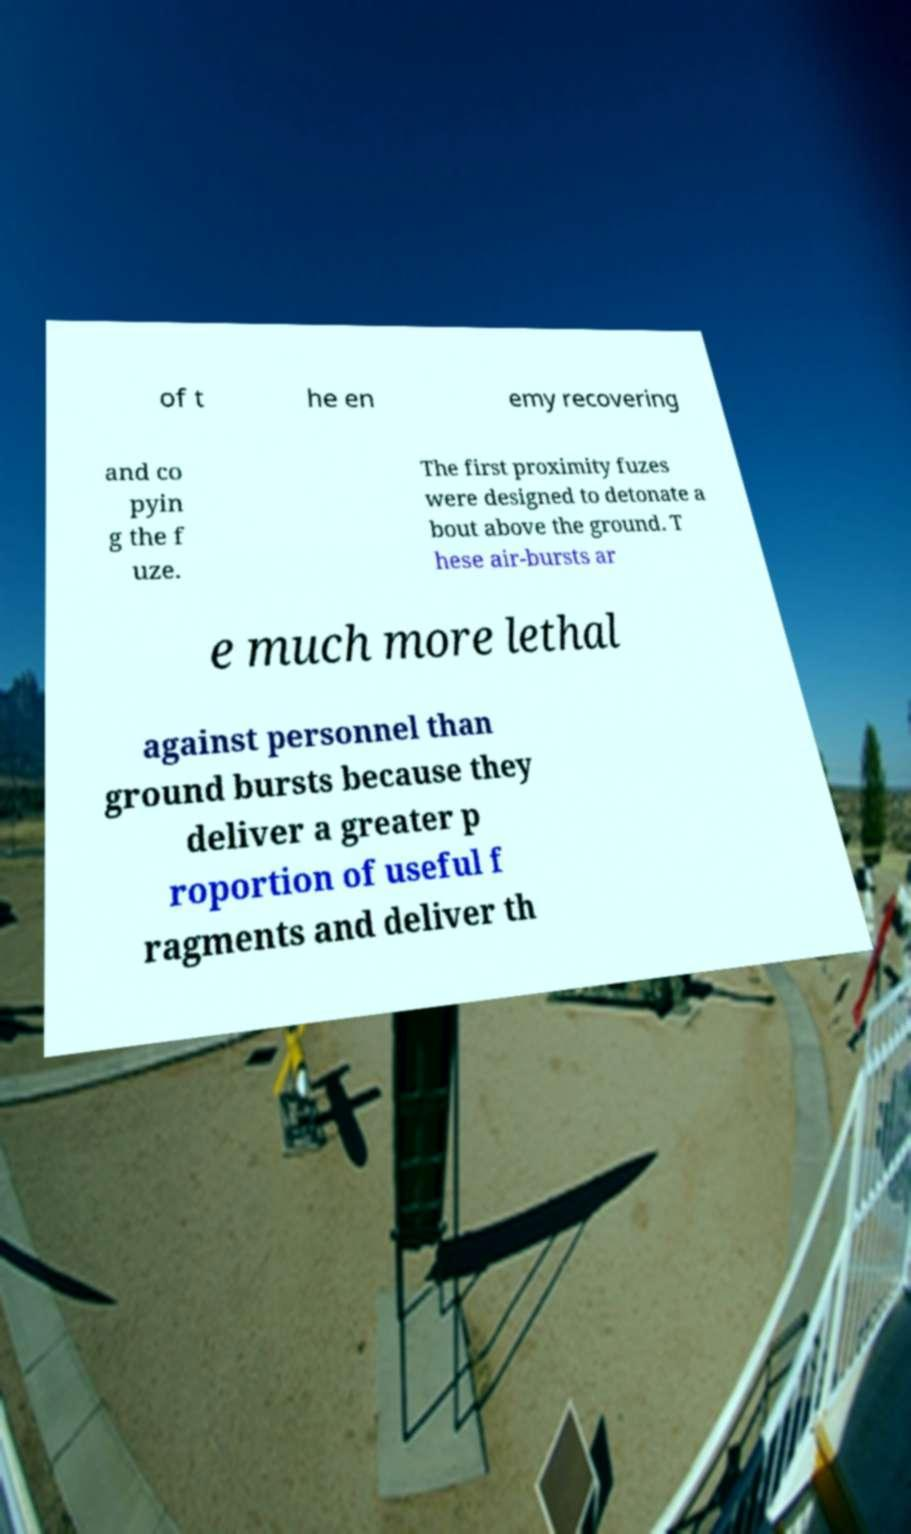Can you read and provide the text displayed in the image?This photo seems to have some interesting text. Can you extract and type it out for me? of t he en emy recovering and co pyin g the f uze. The first proximity fuzes were designed to detonate a bout above the ground. T hese air-bursts ar e much more lethal against personnel than ground bursts because they deliver a greater p roportion of useful f ragments and deliver th 